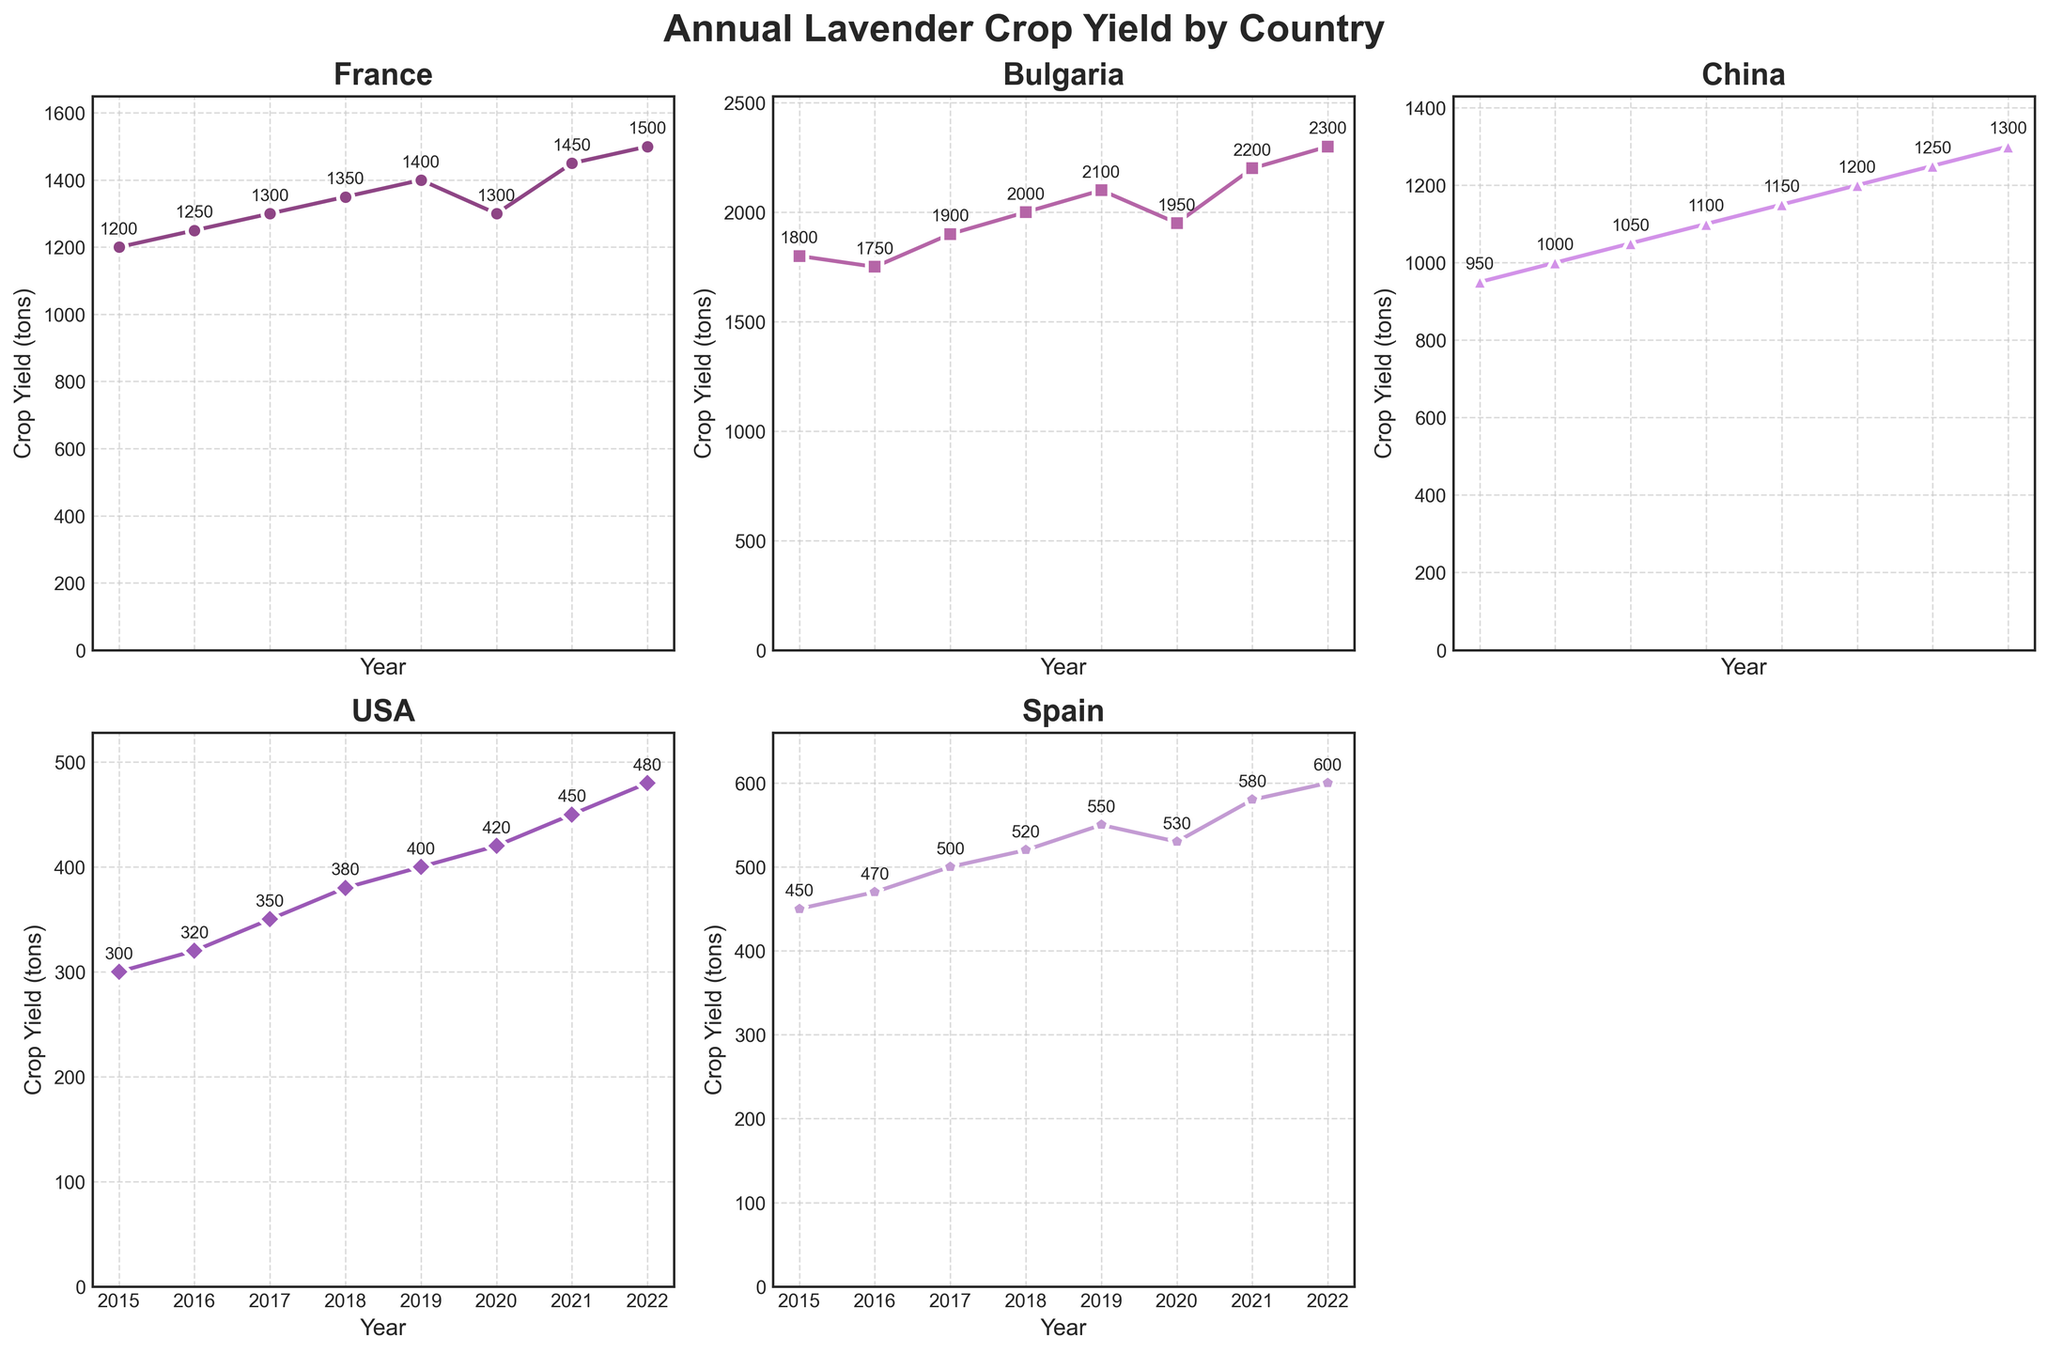What's the title of the figure? The title of the figure is located at the top and is typically in a larger and bolder font size to catch attention. The title summarizes what the figure represents.
Answer: Annual Lavender Crop Yield by Country Which country had the highest lavender crop yield in 2022? By looking at the data points on the chart for the year 2022, you can identify which country has the highest yield by comparing the heights of the lines at that specific year.
Answer: Bulgaria How did the crop yield in France change from 2015 to 2022? To determine the change in yield, note the data points for France in 2015 and 2022 and calculate the difference.
Answer: Increased by 300 tons Which country had the most stable yield from 2015 to 2022? Look for the country whose line plot shows the least variation in height across the years. Stability implies minimal changes upward or downward.
Answer: USA What was the average crop yield in Spain from 2015 to 2022? To find the average, sum all the yield values for Spain between 2015 and 2022 and then divide by the number of years. The data points for Spain are 450, 470, 500, 520, 550, 530, 580, and 600. Sum these values (450+470+500+520+550+530+580+600) and divide by 8.
Answer: 525 tons Compare the trends for China and the USA from 2015 to 2022. Which country's yield increased more? Examine the slopes of the lines for China and the USA between 2015 and 2022. Calculate the difference in crop yield for both countries between these years.
Answer: China's yield increased more What is the total crop yield for all countries combined in 2019? Add the yields for each country in 2019 by summing all the data points for that year. The values are France: 1400, Bulgaria: 2100, China: 1150, USA: 400, and Spain: 550. Sum these values (1400+2100+1150+400+550).
Answer: 5600 tons What year did Bulgaria reach a crop yield of over 2000 tons? Review Bulgaria's data points for the years 2015 to 2022 and identify the first year where the crop yield exceeds 2000 tons.
Answer: 2018 How does the yield in Bulgaria in 2020 compare to that in 2019? Check the values for Bulgaria in 2019 and 2020 and find the difference to see if there was an increase or decrease.
Answer: Decreased by 150 tons 